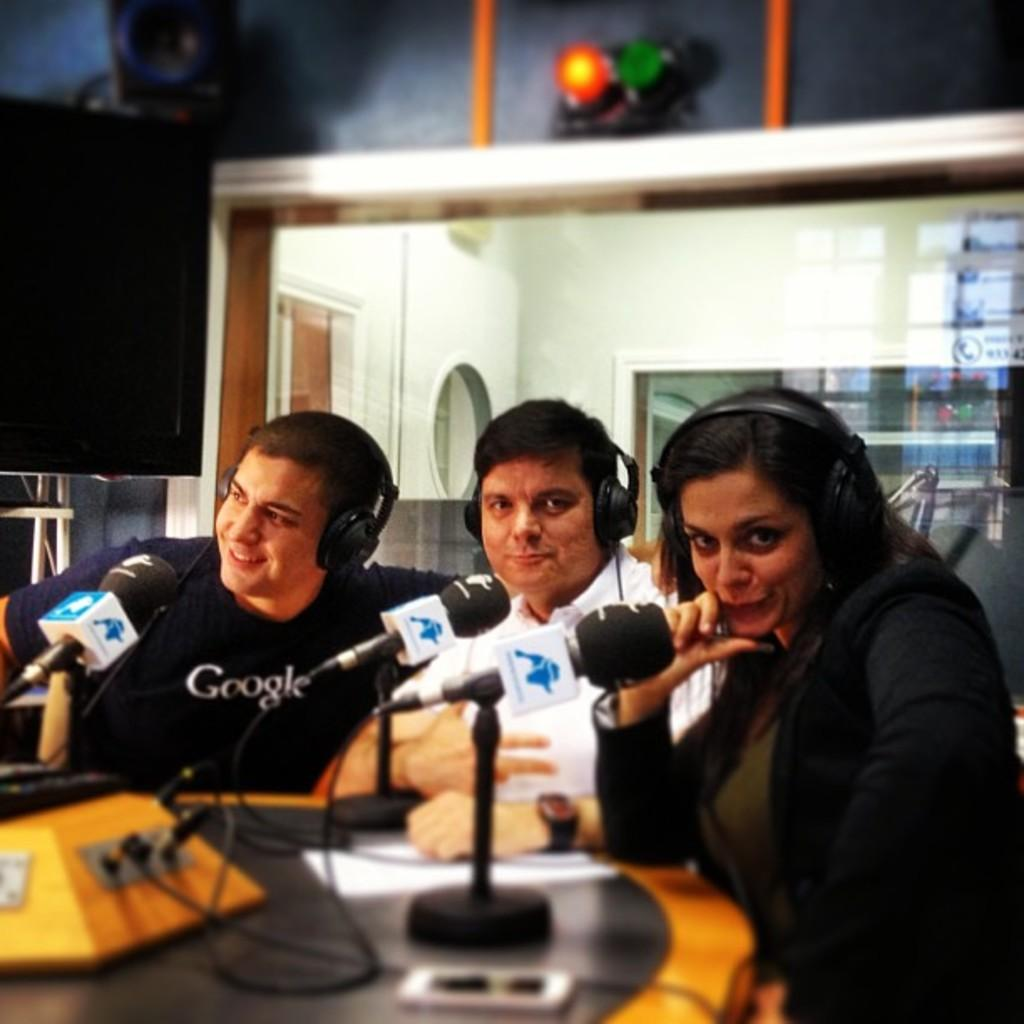What are the people in the image doing? The people in the image are sitting on chairs. What are the people wearing while sitting on the chairs? The people are wearing headphones. What object is present on the table in front of the people? There is a microphone on a table in front of the people. What type of mint is growing on the sidewalk in the image? There is no mint or sidewalk present in the image; the image features people sitting on chairs with headphones and a microphone on a table. 